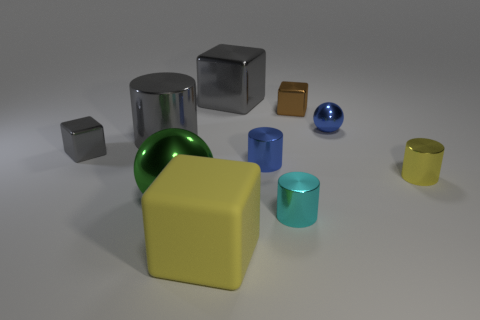Is there a cyan metallic object of the same size as the brown metallic block?
Your response must be concise. Yes. There is a gray metal cube that is in front of the object that is behind the small brown metal block; how big is it?
Provide a short and direct response. Small. Is the number of tiny blue shiny cylinders in front of the yellow metallic thing less than the number of tiny yellow shiny objects?
Keep it short and to the point. Yes. Is the large cylinder the same color as the small metallic sphere?
Make the answer very short. No. The green sphere is what size?
Provide a short and direct response. Large. How many tiny objects have the same color as the tiny ball?
Your response must be concise. 1. There is a shiny ball left of the small shiny cylinder on the left side of the small cyan cylinder; is there a large shiny ball that is on the left side of it?
Ensure brevity in your answer.  No. There is a yellow matte thing that is the same size as the green metallic ball; what shape is it?
Offer a terse response. Cube. How many tiny objects are yellow metal spheres or blue metallic objects?
Your answer should be very brief. 2. There is a large ball that is made of the same material as the yellow cylinder; what color is it?
Your response must be concise. Green. 